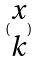<formula> <loc_0><loc_0><loc_500><loc_500>( \begin{matrix} x \\ k \end{matrix} )</formula> 